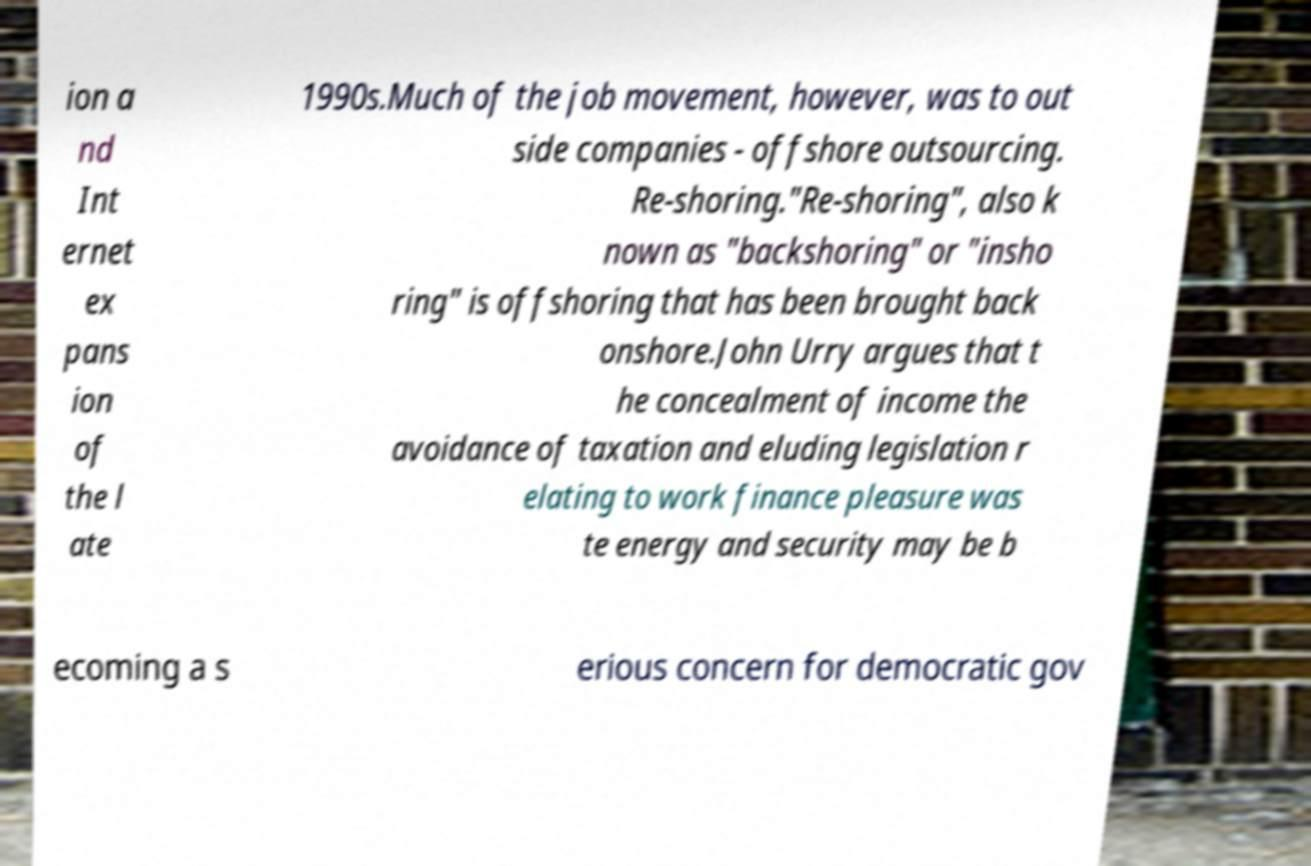Can you read and provide the text displayed in the image?This photo seems to have some interesting text. Can you extract and type it out for me? ion a nd Int ernet ex pans ion of the l ate 1990s.Much of the job movement, however, was to out side companies - offshore outsourcing. Re-shoring."Re-shoring", also k nown as "backshoring" or "insho ring" is offshoring that has been brought back onshore.John Urry argues that t he concealment of income the avoidance of taxation and eluding legislation r elating to work finance pleasure was te energy and security may be b ecoming a s erious concern for democratic gov 